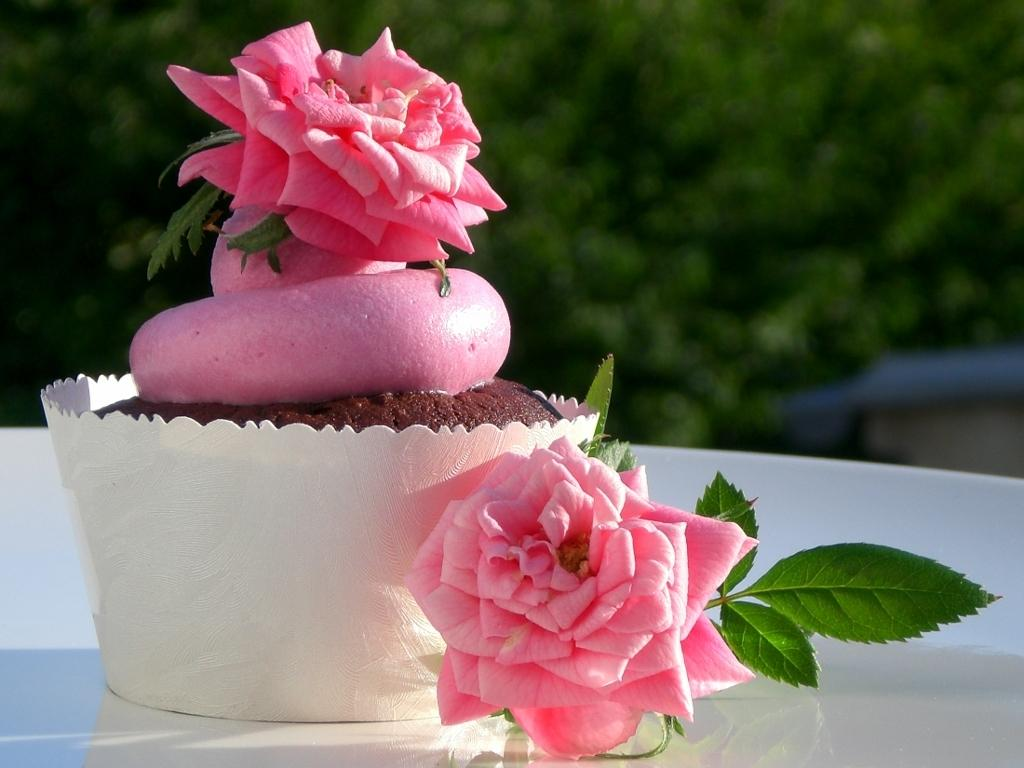What is the color of the table in the image? The table is white in color. What type of dessert can be seen on the table? There is a cupcake with cream on the table. What type of flowers are present on the table? There are two pink rose flowers with leaves on the table. What color is the background in the image? The background appears green in color. What type of humor can be seen in the image? There is no humor present in the image; it is a still image of a table with a cupcake, flowers, and a white table. 